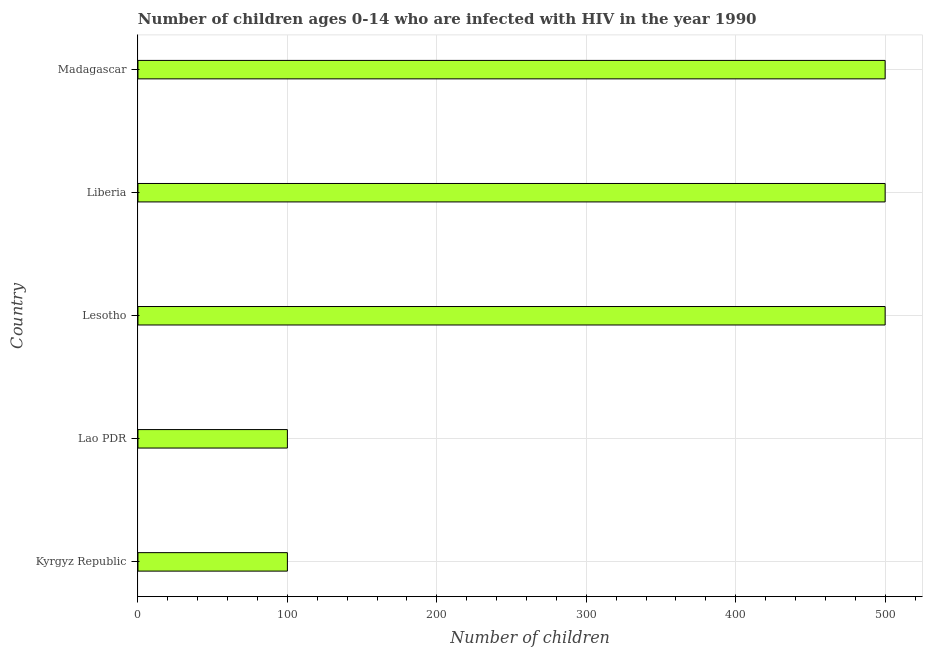Does the graph contain any zero values?
Make the answer very short. No. What is the title of the graph?
Provide a short and direct response. Number of children ages 0-14 who are infected with HIV in the year 1990. What is the label or title of the X-axis?
Offer a very short reply. Number of children. What is the label or title of the Y-axis?
Provide a succinct answer. Country. What is the number of children living with hiv in Liberia?
Provide a succinct answer. 500. Across all countries, what is the maximum number of children living with hiv?
Make the answer very short. 500. Across all countries, what is the minimum number of children living with hiv?
Offer a terse response. 100. In which country was the number of children living with hiv maximum?
Your response must be concise. Lesotho. In which country was the number of children living with hiv minimum?
Your response must be concise. Kyrgyz Republic. What is the sum of the number of children living with hiv?
Offer a very short reply. 1700. What is the difference between the number of children living with hiv in Lesotho and Madagascar?
Make the answer very short. 0. What is the average number of children living with hiv per country?
Your answer should be very brief. 340. In how many countries, is the number of children living with hiv greater than 140 ?
Provide a succinct answer. 3. What is the ratio of the number of children living with hiv in Lao PDR to that in Liberia?
Make the answer very short. 0.2. Is the sum of the number of children living with hiv in Lesotho and Liberia greater than the maximum number of children living with hiv across all countries?
Provide a short and direct response. Yes. What is the difference between the highest and the lowest number of children living with hiv?
Provide a short and direct response. 400. How many bars are there?
Offer a terse response. 5. Are all the bars in the graph horizontal?
Your answer should be compact. Yes. Are the values on the major ticks of X-axis written in scientific E-notation?
Make the answer very short. No. What is the Number of children in Lao PDR?
Your answer should be compact. 100. What is the Number of children in Lesotho?
Make the answer very short. 500. What is the difference between the Number of children in Kyrgyz Republic and Lesotho?
Your answer should be compact. -400. What is the difference between the Number of children in Kyrgyz Republic and Liberia?
Give a very brief answer. -400. What is the difference between the Number of children in Kyrgyz Republic and Madagascar?
Ensure brevity in your answer.  -400. What is the difference between the Number of children in Lao PDR and Lesotho?
Give a very brief answer. -400. What is the difference between the Number of children in Lao PDR and Liberia?
Your answer should be compact. -400. What is the difference between the Number of children in Lao PDR and Madagascar?
Your answer should be very brief. -400. What is the difference between the Number of children in Lesotho and Liberia?
Give a very brief answer. 0. What is the difference between the Number of children in Lesotho and Madagascar?
Make the answer very short. 0. What is the ratio of the Number of children in Lao PDR to that in Lesotho?
Offer a terse response. 0.2. What is the ratio of the Number of children in Lao PDR to that in Madagascar?
Provide a succinct answer. 0.2. What is the ratio of the Number of children in Lesotho to that in Liberia?
Ensure brevity in your answer.  1. What is the ratio of the Number of children in Lesotho to that in Madagascar?
Your response must be concise. 1. 